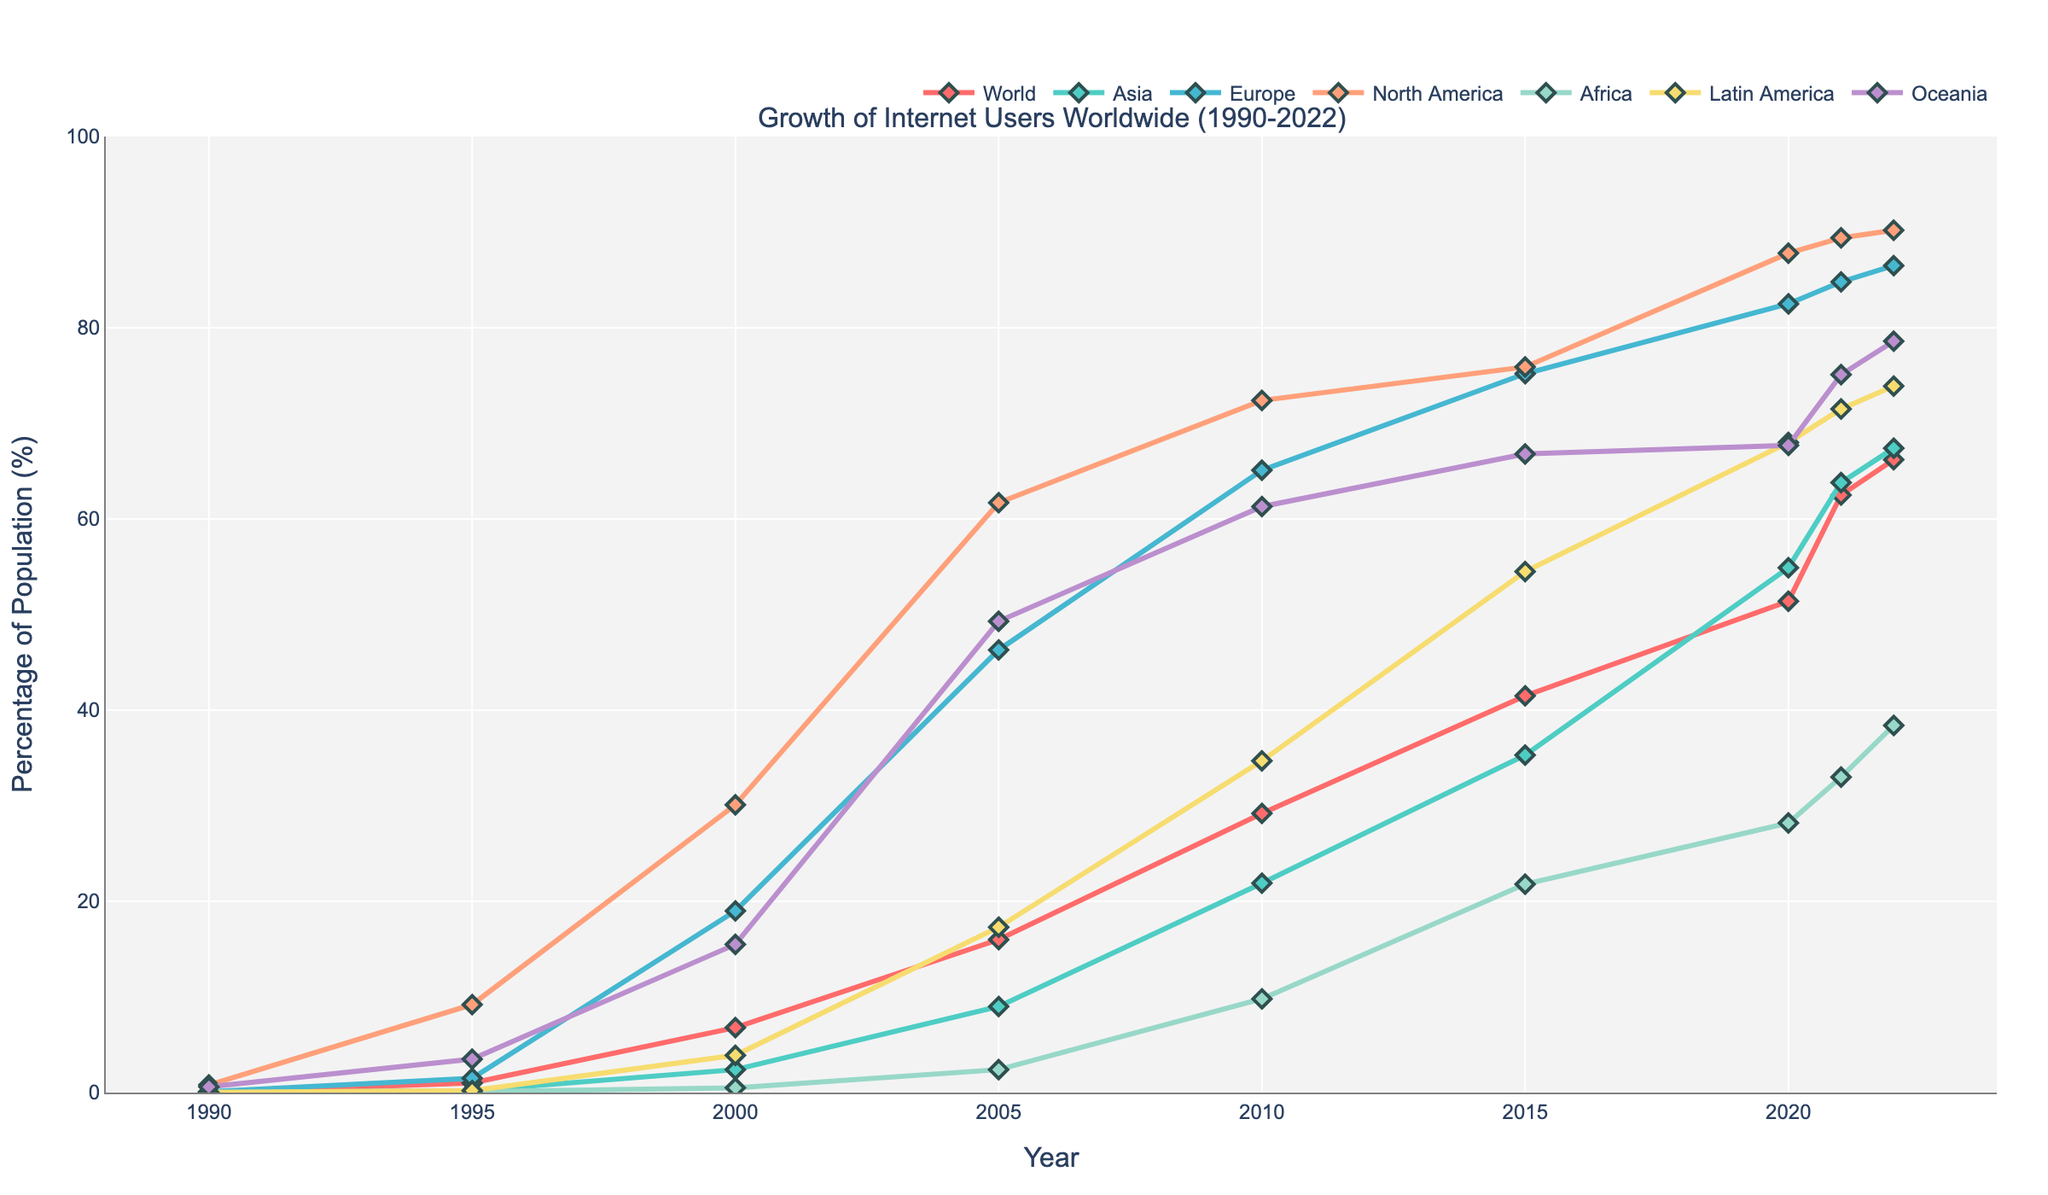Which regions surpassed 50% internet usage first? Observe the progression of each region's line. Identify which regions crossed the 50% mark initially. North America surpassed 50% in 2000, while Oceania followed in 2005.
Answer: North America and Oceania In what year did Africa see the steepest increase in internet users, and estimate the percentage difference during that interval? Examine Africa's line for the fastest rising segment. From 2010 to 2015, the slope is steepest. The percentage increased from 9.8% to 21.8%, hence the difference is 21.8 - 9.8 = 12%.
Answer: 2010 to 2015, 12% Compare the internet user growth in Asia and Latin America from 2000 to 2020. Which region had higher growth, and by what percentage? Notice Asia's and Latin America's lines in 2000 and 2020. Asia grew from 2.4% to 54.9%, while Latin America grew from 3.9% to 68%. The growth percentages are (54.9 - 2.4) = 52.5% for Asia and (68 - 3.9) = 64.1% for Latin America. Latin America had higher growth by 64.1% - 52.5% = 11.6%.
Answer: Latin America by 11.6% Identify the two regions with closely following trends after 2010. After 2010, examine the trends that visually align closely. Oceania and Europe show similar growth patterns post-2010. Their lines often come closest, reflecting parallel growth.
Answer: Oceania and Europe Between 2010 and 2020, which region exhibited the slowest growth in internet users? Evaluate the slope between 2010 and 2020 for all regions. The region with the least steep slope reflects the slowest growth. Europe shows the least increase, starting from 65.1% and rising to 82.5%, thus a growth of 17.4%.
Answer: Europe By how much did the world average internet usage increase between 2000 and 2021? Compare the world average internet usage percentage in 2000 and 2021. The values are 6.8% in 2000 and 62.5% in 2021. The increase is 62.5 - 6.8 = 55.7%.
Answer: 55.7% Which region had the smallest percentage of internet users in 1995, and how much did it increase by 2005? Identify the lowest internet usage percentage in 1995, which is Africa at 0.1%. In 2005, Africa reached 2.4%. The increase is 2.4 - 0.1 = 2.3%.
Answer: Africa, 2.3% 